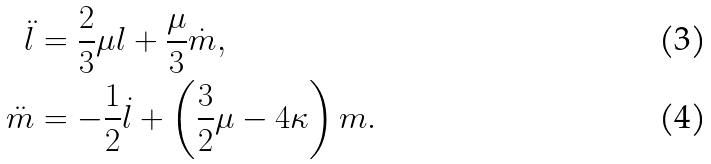Convert formula to latex. <formula><loc_0><loc_0><loc_500><loc_500>\ddot { l } & = \frac { 2 } { 3 } \mu l + \frac { \mu } { 3 } \dot { m } , \\ \ddot { m } & = - \frac { 1 } { 2 } \dot { l } + \left ( \frac { 3 } { 2 } \mu - 4 \kappa \right ) m .</formula> 